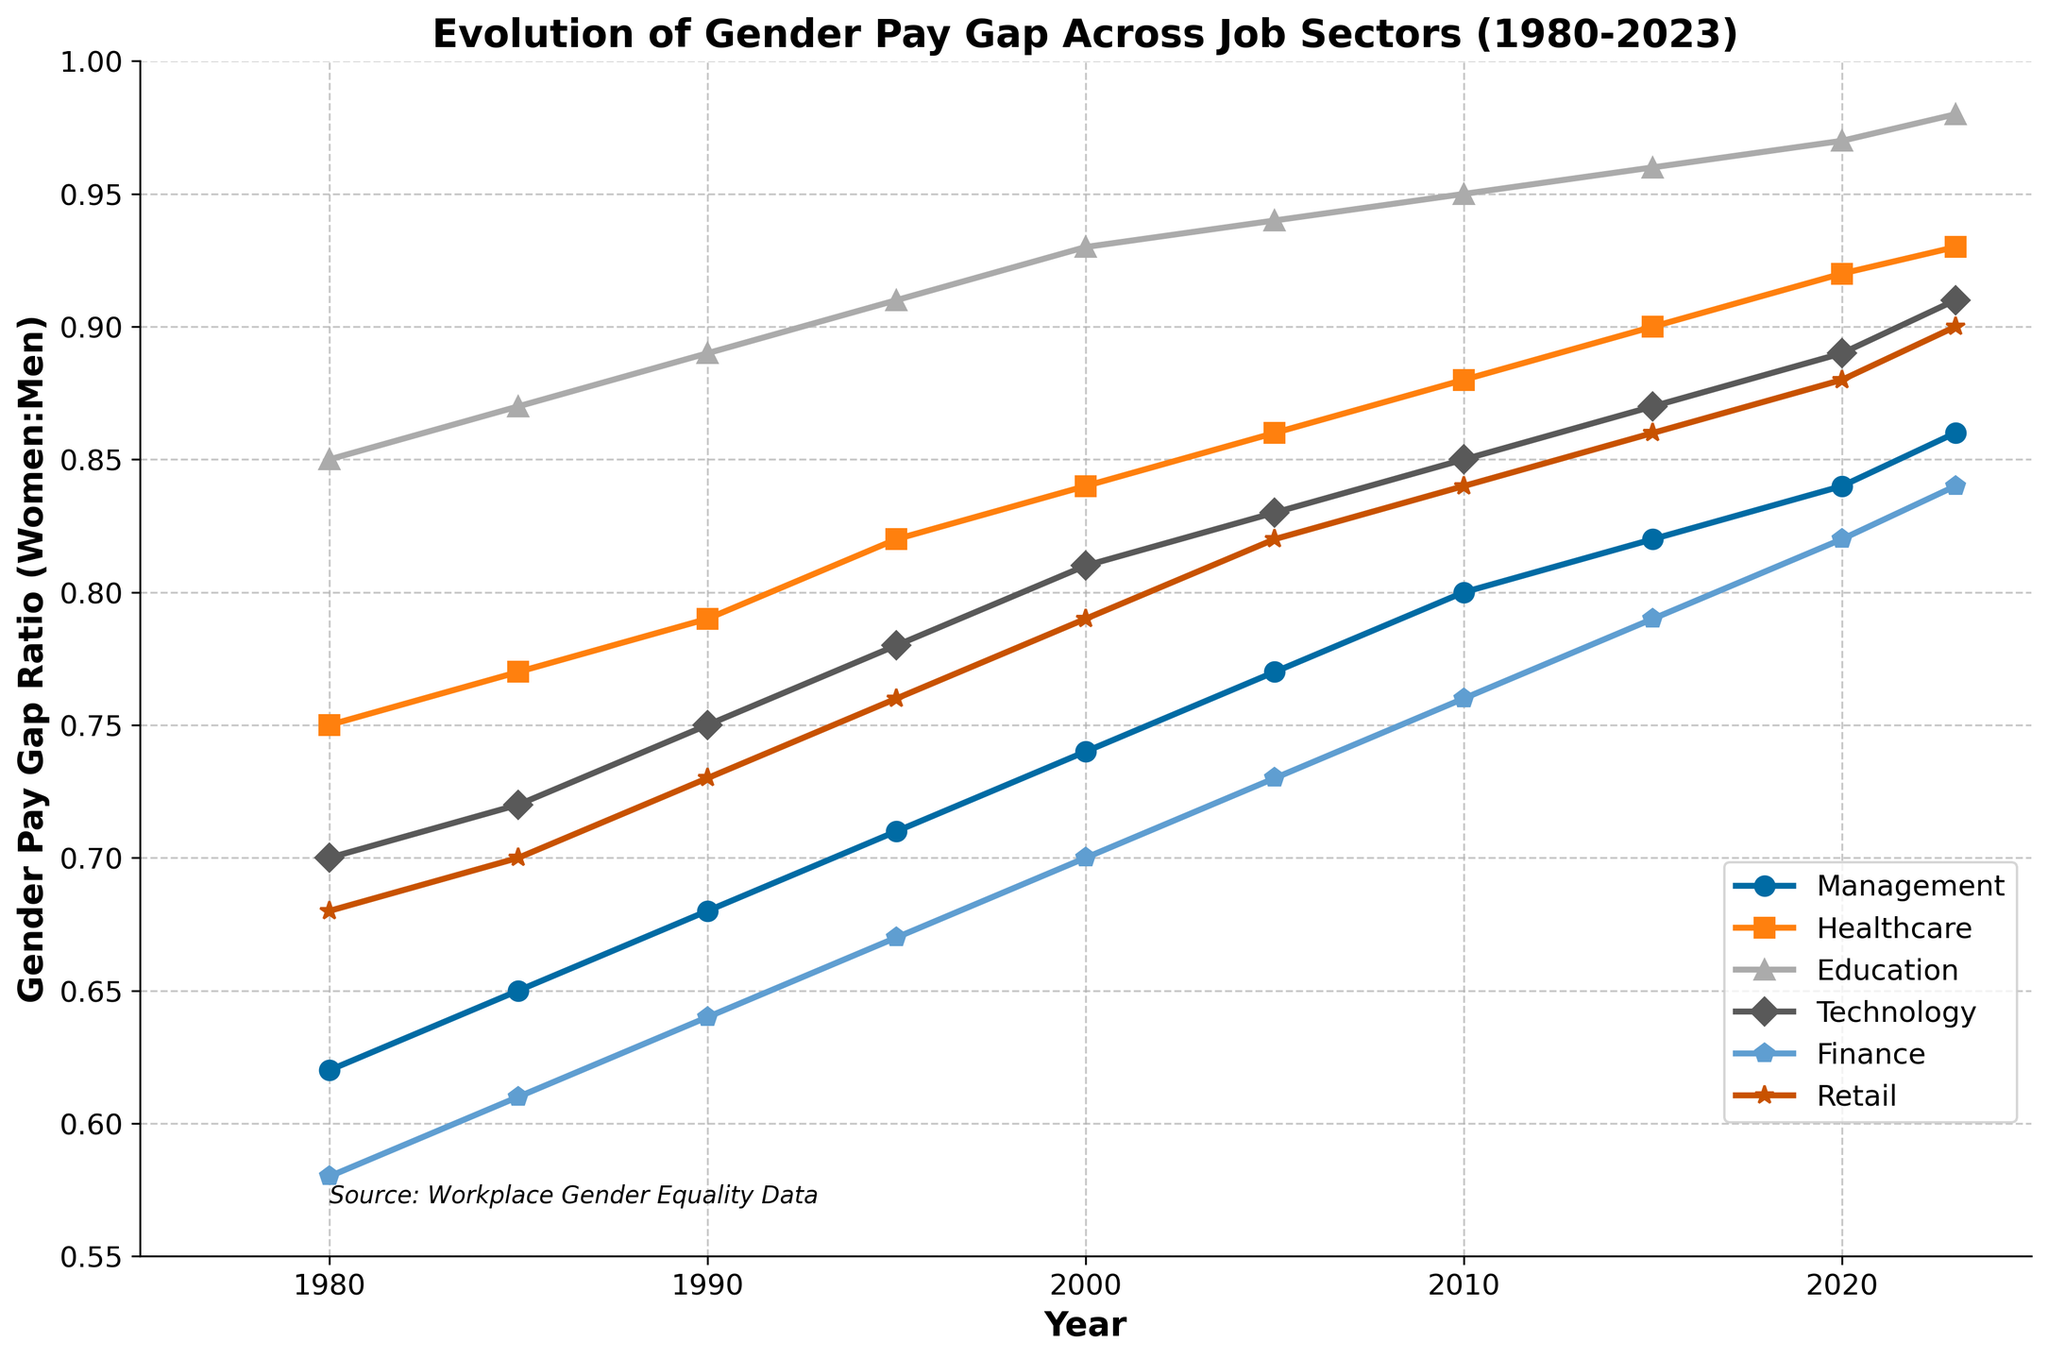What trend do you observe in the gender pay gap ratio in the Retail sector from 1980 to 2023? The line representing the Retail sector shows a consistent upward trend from 0.68 in 1980 to 0.90 in 2023.
Answer: The gender pay gap ratio in the Retail sector has consistently improved from 1980 to 2023 Which sector had the smallest gender pay gap ratio in 1980? By comparing the starting points in 1980 on the Y-axis across all sectors, Education (0.85) had the smallest gender pay gap ratio.
Answer: Education In which year did the Technology sector achieve a gender pay gap ratio of 0.85? Looking at the line representing the Technology sector, 0.85 is reached in 2010.
Answer: 2010 Between 2000 and 2023, which sector had the greatest increase in its gender pay gap ratio? Subtract the gender pay gap ratios in 2000 from those in 2023 for each sector and compare. Technology had the greatest increase of 0.1 (0.91 - 0.81).
Answer: Technology How did the gender pay gap in the Finance sector change between 1980 and 2023? By comparing values in Finance from 1980 (0.58) and 2023 (0.84), the ratio increased by 0.26.
Answer: The gender pay gap ratio increased by 0.26 Which sectors achieved a gender pay gap ratio above 0.90 by 2023? Visual inspection shows Healthcare (0.93), Education (0.98), Technology (0.91), and Retail (0.90) all had ratios above 0.90 by 2023.
Answer: Healthcare, Education, Technology, Retail What is the average gender pay gap ratio across all sectors for the year 2023? Adding the ratios for all sectors in 2023: (0.86 + 0.93 + 0.98 + 0.91 + 0.84 + 0.90) = 5.42, then dividing by 6 sectors, the average is 0.903
Answer: 0.903 Which sector had the steepest increase in its gender pay gap ratio between 1980 and 2000? Calculating the increase for each sector over these years: Management (0.74 - 0.62 = 0.12), Healthcare (0.84 - 0.75 = 0.09), Education (0.93 - 0.85 = 0.08), Technology (0.81 - 0.70 = 0.11), Finance (0.70 - 0.58 = 0.12), Retail (0.79 - 0.68 = 0.11). Management and Finance had the steepest increase.
Answer: Management and Finance 